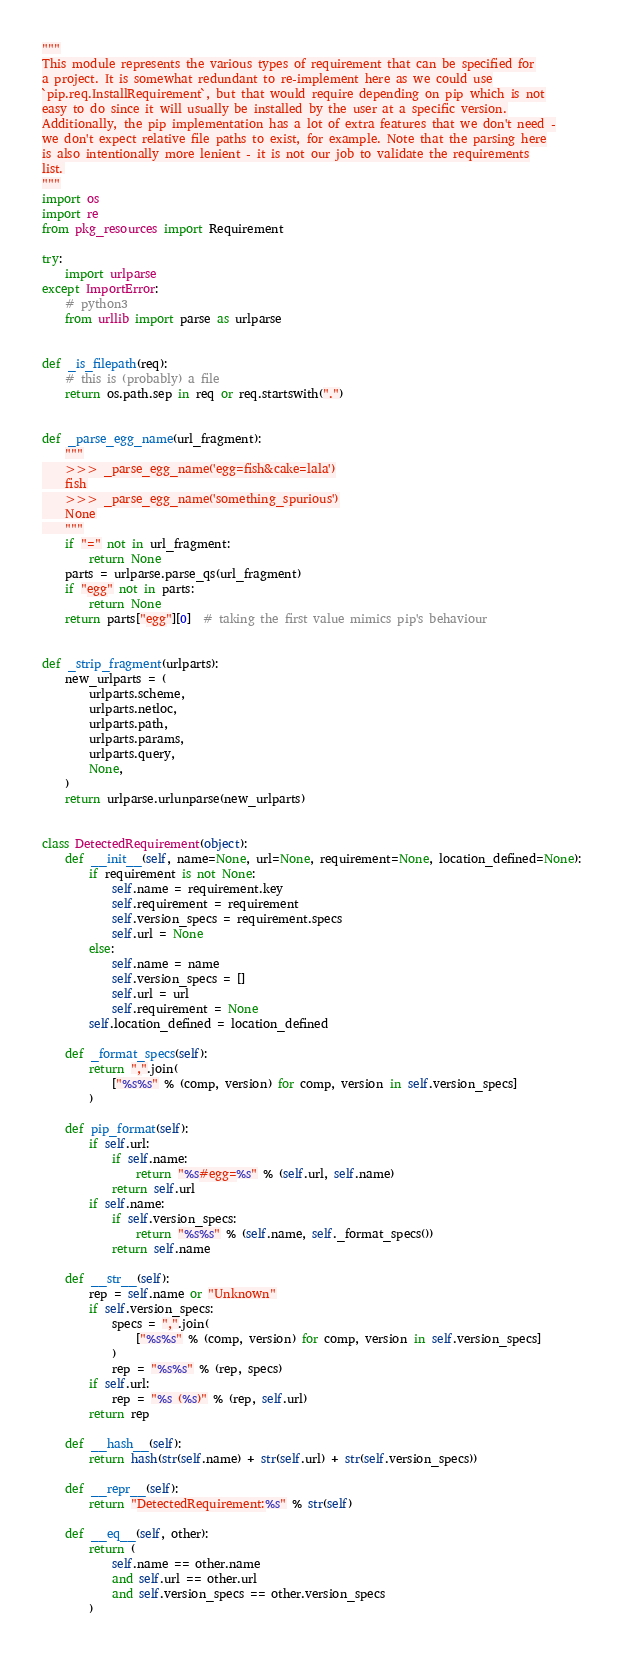<code> <loc_0><loc_0><loc_500><loc_500><_Python_>"""
This module represents the various types of requirement that can be specified for
a project. It is somewhat redundant to re-implement here as we could use
`pip.req.InstallRequirement`, but that would require depending on pip which is not
easy to do since it will usually be installed by the user at a specific version.
Additionally, the pip implementation has a lot of extra features that we don't need -
we don't expect relative file paths to exist, for example. Note that the parsing here
is also intentionally more lenient - it is not our job to validate the requirements
list.
"""
import os
import re
from pkg_resources import Requirement

try:
    import urlparse
except ImportError:
    # python3
    from urllib import parse as urlparse


def _is_filepath(req):
    # this is (probably) a file
    return os.path.sep in req or req.startswith(".")


def _parse_egg_name(url_fragment):
    """
    >>> _parse_egg_name('egg=fish&cake=lala')
    fish
    >>> _parse_egg_name('something_spurious')
    None
    """
    if "=" not in url_fragment:
        return None
    parts = urlparse.parse_qs(url_fragment)
    if "egg" not in parts:
        return None
    return parts["egg"][0]  # taking the first value mimics pip's behaviour


def _strip_fragment(urlparts):
    new_urlparts = (
        urlparts.scheme,
        urlparts.netloc,
        urlparts.path,
        urlparts.params,
        urlparts.query,
        None,
    )
    return urlparse.urlunparse(new_urlparts)


class DetectedRequirement(object):
    def __init__(self, name=None, url=None, requirement=None, location_defined=None):
        if requirement is not None:
            self.name = requirement.key
            self.requirement = requirement
            self.version_specs = requirement.specs
            self.url = None
        else:
            self.name = name
            self.version_specs = []
            self.url = url
            self.requirement = None
        self.location_defined = location_defined

    def _format_specs(self):
        return ",".join(
            ["%s%s" % (comp, version) for comp, version in self.version_specs]
        )

    def pip_format(self):
        if self.url:
            if self.name:
                return "%s#egg=%s" % (self.url, self.name)
            return self.url
        if self.name:
            if self.version_specs:
                return "%s%s" % (self.name, self._format_specs())
            return self.name

    def __str__(self):
        rep = self.name or "Unknown"
        if self.version_specs:
            specs = ",".join(
                ["%s%s" % (comp, version) for comp, version in self.version_specs]
            )
            rep = "%s%s" % (rep, specs)
        if self.url:
            rep = "%s (%s)" % (rep, self.url)
        return rep

    def __hash__(self):
        return hash(str(self.name) + str(self.url) + str(self.version_specs))

    def __repr__(self):
        return "DetectedRequirement:%s" % str(self)

    def __eq__(self, other):
        return (
            self.name == other.name
            and self.url == other.url
            and self.version_specs == other.version_specs
        )
</code> 